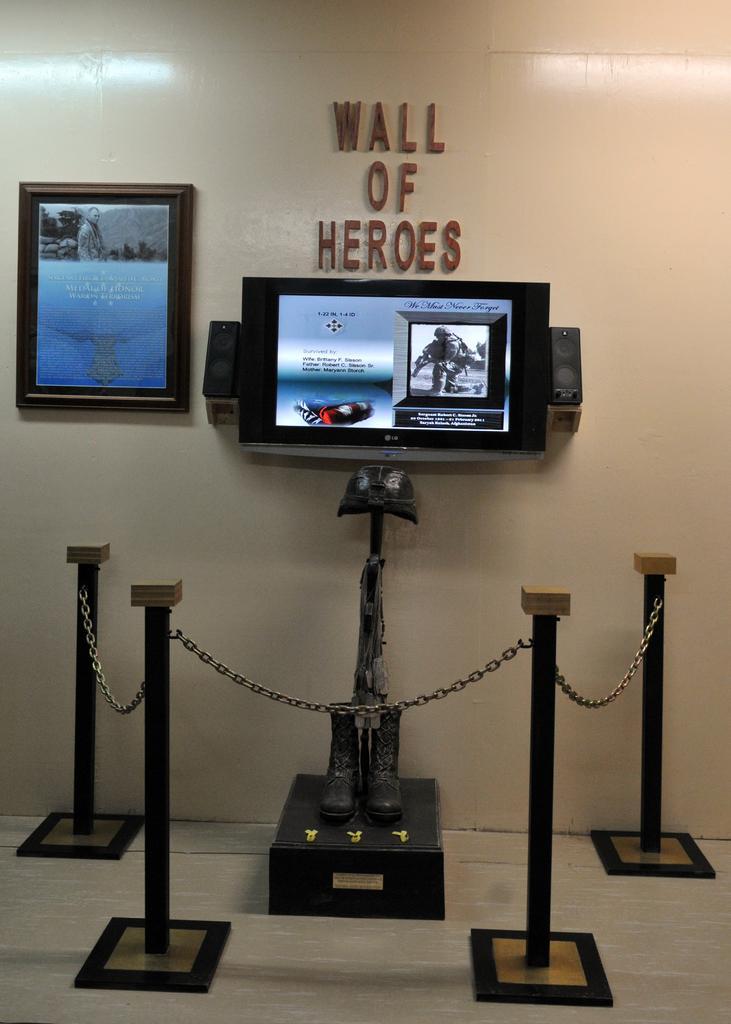How would you summarize this image in a sentence or two? In this image I can see a fence, poles, shoes, TV, speakers, photo frame, text and wall. This image is taken may be in a hall. 